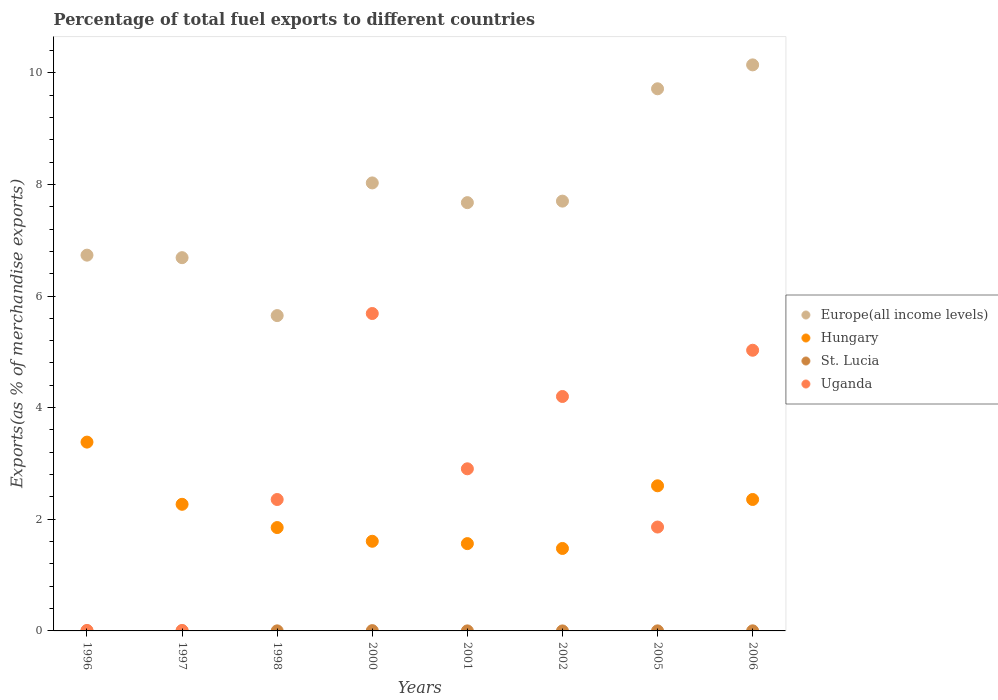How many different coloured dotlines are there?
Provide a short and direct response. 4. Is the number of dotlines equal to the number of legend labels?
Ensure brevity in your answer.  Yes. What is the percentage of exports to different countries in St. Lucia in 2002?
Ensure brevity in your answer.  4.657797227082891e-6. Across all years, what is the maximum percentage of exports to different countries in St. Lucia?
Give a very brief answer. 0.01. Across all years, what is the minimum percentage of exports to different countries in Uganda?
Provide a short and direct response. 0.01. What is the total percentage of exports to different countries in Europe(all income levels) in the graph?
Keep it short and to the point. 62.32. What is the difference between the percentage of exports to different countries in Hungary in 1996 and that in 2006?
Offer a terse response. 1.03. What is the difference between the percentage of exports to different countries in Uganda in 2000 and the percentage of exports to different countries in Hungary in 2001?
Ensure brevity in your answer.  4.12. What is the average percentage of exports to different countries in Hungary per year?
Make the answer very short. 2.14. In the year 1998, what is the difference between the percentage of exports to different countries in St. Lucia and percentage of exports to different countries in Uganda?
Your answer should be compact. -2.35. What is the ratio of the percentage of exports to different countries in Uganda in 2000 to that in 2005?
Your answer should be very brief. 3.06. What is the difference between the highest and the second highest percentage of exports to different countries in Uganda?
Your answer should be compact. 0.66. What is the difference between the highest and the lowest percentage of exports to different countries in St. Lucia?
Offer a terse response. 0.01. Is it the case that in every year, the sum of the percentage of exports to different countries in Hungary and percentage of exports to different countries in Europe(all income levels)  is greater than the percentage of exports to different countries in St. Lucia?
Give a very brief answer. Yes. Is the percentage of exports to different countries in St. Lucia strictly greater than the percentage of exports to different countries in Uganda over the years?
Give a very brief answer. No. Is the percentage of exports to different countries in St. Lucia strictly less than the percentage of exports to different countries in Hungary over the years?
Provide a succinct answer. Yes. How many years are there in the graph?
Ensure brevity in your answer.  8. What is the difference between two consecutive major ticks on the Y-axis?
Your response must be concise. 2. How many legend labels are there?
Make the answer very short. 4. What is the title of the graph?
Offer a terse response. Percentage of total fuel exports to different countries. Does "Bosnia and Herzegovina" appear as one of the legend labels in the graph?
Keep it short and to the point. No. What is the label or title of the X-axis?
Your answer should be very brief. Years. What is the label or title of the Y-axis?
Provide a short and direct response. Exports(as % of merchandise exports). What is the Exports(as % of merchandise exports) of Europe(all income levels) in 1996?
Provide a short and direct response. 6.73. What is the Exports(as % of merchandise exports) in Hungary in 1996?
Offer a terse response. 3.38. What is the Exports(as % of merchandise exports) in St. Lucia in 1996?
Your answer should be very brief. 0. What is the Exports(as % of merchandise exports) in Uganda in 1996?
Give a very brief answer. 0.01. What is the Exports(as % of merchandise exports) in Europe(all income levels) in 1997?
Keep it short and to the point. 6.69. What is the Exports(as % of merchandise exports) of Hungary in 1997?
Give a very brief answer. 2.27. What is the Exports(as % of merchandise exports) in St. Lucia in 1997?
Ensure brevity in your answer.  0. What is the Exports(as % of merchandise exports) of Uganda in 1997?
Make the answer very short. 0.01. What is the Exports(as % of merchandise exports) in Europe(all income levels) in 1998?
Offer a terse response. 5.65. What is the Exports(as % of merchandise exports) of Hungary in 1998?
Your answer should be very brief. 1.85. What is the Exports(as % of merchandise exports) of St. Lucia in 1998?
Provide a short and direct response. 0. What is the Exports(as % of merchandise exports) of Uganda in 1998?
Your answer should be compact. 2.35. What is the Exports(as % of merchandise exports) of Europe(all income levels) in 2000?
Give a very brief answer. 8.03. What is the Exports(as % of merchandise exports) of Hungary in 2000?
Your response must be concise. 1.61. What is the Exports(as % of merchandise exports) in St. Lucia in 2000?
Offer a very short reply. 0.01. What is the Exports(as % of merchandise exports) of Uganda in 2000?
Offer a terse response. 5.69. What is the Exports(as % of merchandise exports) in Europe(all income levels) in 2001?
Make the answer very short. 7.67. What is the Exports(as % of merchandise exports) in Hungary in 2001?
Offer a very short reply. 1.56. What is the Exports(as % of merchandise exports) of St. Lucia in 2001?
Offer a terse response. 0. What is the Exports(as % of merchandise exports) in Uganda in 2001?
Your answer should be very brief. 2.9. What is the Exports(as % of merchandise exports) in Europe(all income levels) in 2002?
Ensure brevity in your answer.  7.7. What is the Exports(as % of merchandise exports) of Hungary in 2002?
Offer a terse response. 1.48. What is the Exports(as % of merchandise exports) of St. Lucia in 2002?
Your response must be concise. 4.657797227082891e-6. What is the Exports(as % of merchandise exports) in Uganda in 2002?
Offer a very short reply. 4.2. What is the Exports(as % of merchandise exports) in Europe(all income levels) in 2005?
Provide a short and direct response. 9.71. What is the Exports(as % of merchandise exports) of Hungary in 2005?
Your response must be concise. 2.6. What is the Exports(as % of merchandise exports) in St. Lucia in 2005?
Give a very brief answer. 0. What is the Exports(as % of merchandise exports) in Uganda in 2005?
Your response must be concise. 1.86. What is the Exports(as % of merchandise exports) of Europe(all income levels) in 2006?
Provide a succinct answer. 10.14. What is the Exports(as % of merchandise exports) in Hungary in 2006?
Make the answer very short. 2.35. What is the Exports(as % of merchandise exports) in St. Lucia in 2006?
Give a very brief answer. 0. What is the Exports(as % of merchandise exports) of Uganda in 2006?
Make the answer very short. 5.03. Across all years, what is the maximum Exports(as % of merchandise exports) in Europe(all income levels)?
Give a very brief answer. 10.14. Across all years, what is the maximum Exports(as % of merchandise exports) in Hungary?
Your answer should be compact. 3.38. Across all years, what is the maximum Exports(as % of merchandise exports) in St. Lucia?
Offer a very short reply. 0.01. Across all years, what is the maximum Exports(as % of merchandise exports) of Uganda?
Give a very brief answer. 5.69. Across all years, what is the minimum Exports(as % of merchandise exports) of Europe(all income levels)?
Your response must be concise. 5.65. Across all years, what is the minimum Exports(as % of merchandise exports) of Hungary?
Make the answer very short. 1.48. Across all years, what is the minimum Exports(as % of merchandise exports) in St. Lucia?
Your response must be concise. 4.657797227082891e-6. Across all years, what is the minimum Exports(as % of merchandise exports) of Uganda?
Your answer should be compact. 0.01. What is the total Exports(as % of merchandise exports) in Europe(all income levels) in the graph?
Offer a very short reply. 62.32. What is the total Exports(as % of merchandise exports) in Hungary in the graph?
Offer a very short reply. 17.11. What is the total Exports(as % of merchandise exports) in St. Lucia in the graph?
Give a very brief answer. 0.01. What is the total Exports(as % of merchandise exports) in Uganda in the graph?
Provide a succinct answer. 22.05. What is the difference between the Exports(as % of merchandise exports) of Europe(all income levels) in 1996 and that in 1997?
Ensure brevity in your answer.  0.04. What is the difference between the Exports(as % of merchandise exports) in Hungary in 1996 and that in 1997?
Provide a short and direct response. 1.11. What is the difference between the Exports(as % of merchandise exports) of St. Lucia in 1996 and that in 1997?
Give a very brief answer. -0. What is the difference between the Exports(as % of merchandise exports) of Uganda in 1996 and that in 1997?
Offer a terse response. 0. What is the difference between the Exports(as % of merchandise exports) in Europe(all income levels) in 1996 and that in 1998?
Give a very brief answer. 1.08. What is the difference between the Exports(as % of merchandise exports) of Hungary in 1996 and that in 1998?
Provide a succinct answer. 1.53. What is the difference between the Exports(as % of merchandise exports) of St. Lucia in 1996 and that in 1998?
Give a very brief answer. -0. What is the difference between the Exports(as % of merchandise exports) in Uganda in 1996 and that in 1998?
Ensure brevity in your answer.  -2.35. What is the difference between the Exports(as % of merchandise exports) of Europe(all income levels) in 1996 and that in 2000?
Offer a very short reply. -1.29. What is the difference between the Exports(as % of merchandise exports) of Hungary in 1996 and that in 2000?
Offer a terse response. 1.78. What is the difference between the Exports(as % of merchandise exports) of St. Lucia in 1996 and that in 2000?
Keep it short and to the point. -0.01. What is the difference between the Exports(as % of merchandise exports) in Uganda in 1996 and that in 2000?
Provide a short and direct response. -5.68. What is the difference between the Exports(as % of merchandise exports) in Europe(all income levels) in 1996 and that in 2001?
Provide a short and direct response. -0.94. What is the difference between the Exports(as % of merchandise exports) of Hungary in 1996 and that in 2001?
Your answer should be compact. 1.82. What is the difference between the Exports(as % of merchandise exports) in St. Lucia in 1996 and that in 2001?
Give a very brief answer. -0. What is the difference between the Exports(as % of merchandise exports) of Uganda in 1996 and that in 2001?
Offer a terse response. -2.9. What is the difference between the Exports(as % of merchandise exports) of Europe(all income levels) in 1996 and that in 2002?
Provide a short and direct response. -0.97. What is the difference between the Exports(as % of merchandise exports) in Hungary in 1996 and that in 2002?
Your response must be concise. 1.91. What is the difference between the Exports(as % of merchandise exports) of St. Lucia in 1996 and that in 2002?
Offer a terse response. 0. What is the difference between the Exports(as % of merchandise exports) in Uganda in 1996 and that in 2002?
Keep it short and to the point. -4.19. What is the difference between the Exports(as % of merchandise exports) in Europe(all income levels) in 1996 and that in 2005?
Your answer should be very brief. -2.98. What is the difference between the Exports(as % of merchandise exports) in Hungary in 1996 and that in 2005?
Give a very brief answer. 0.78. What is the difference between the Exports(as % of merchandise exports) in St. Lucia in 1996 and that in 2005?
Provide a short and direct response. -0. What is the difference between the Exports(as % of merchandise exports) of Uganda in 1996 and that in 2005?
Keep it short and to the point. -1.85. What is the difference between the Exports(as % of merchandise exports) of Europe(all income levels) in 1996 and that in 2006?
Offer a terse response. -3.41. What is the difference between the Exports(as % of merchandise exports) in Hungary in 1996 and that in 2006?
Keep it short and to the point. 1.03. What is the difference between the Exports(as % of merchandise exports) in St. Lucia in 1996 and that in 2006?
Provide a short and direct response. -0. What is the difference between the Exports(as % of merchandise exports) of Uganda in 1996 and that in 2006?
Offer a very short reply. -5.02. What is the difference between the Exports(as % of merchandise exports) of Europe(all income levels) in 1997 and that in 1998?
Offer a very short reply. 1.04. What is the difference between the Exports(as % of merchandise exports) of Hungary in 1997 and that in 1998?
Offer a terse response. 0.42. What is the difference between the Exports(as % of merchandise exports) of St. Lucia in 1997 and that in 1998?
Make the answer very short. -0. What is the difference between the Exports(as % of merchandise exports) of Uganda in 1997 and that in 1998?
Your response must be concise. -2.35. What is the difference between the Exports(as % of merchandise exports) of Europe(all income levels) in 1997 and that in 2000?
Ensure brevity in your answer.  -1.34. What is the difference between the Exports(as % of merchandise exports) of Hungary in 1997 and that in 2000?
Keep it short and to the point. 0.66. What is the difference between the Exports(as % of merchandise exports) in St. Lucia in 1997 and that in 2000?
Your answer should be very brief. -0. What is the difference between the Exports(as % of merchandise exports) in Uganda in 1997 and that in 2000?
Offer a terse response. -5.68. What is the difference between the Exports(as % of merchandise exports) of Europe(all income levels) in 1997 and that in 2001?
Provide a short and direct response. -0.99. What is the difference between the Exports(as % of merchandise exports) of Hungary in 1997 and that in 2001?
Provide a succinct answer. 0.7. What is the difference between the Exports(as % of merchandise exports) of St. Lucia in 1997 and that in 2001?
Provide a succinct answer. 0. What is the difference between the Exports(as % of merchandise exports) in Uganda in 1997 and that in 2001?
Make the answer very short. -2.9. What is the difference between the Exports(as % of merchandise exports) of Europe(all income levels) in 1997 and that in 2002?
Give a very brief answer. -1.01. What is the difference between the Exports(as % of merchandise exports) in Hungary in 1997 and that in 2002?
Keep it short and to the point. 0.79. What is the difference between the Exports(as % of merchandise exports) of St. Lucia in 1997 and that in 2002?
Offer a terse response. 0. What is the difference between the Exports(as % of merchandise exports) in Uganda in 1997 and that in 2002?
Provide a short and direct response. -4.19. What is the difference between the Exports(as % of merchandise exports) of Europe(all income levels) in 1997 and that in 2005?
Make the answer very short. -3.03. What is the difference between the Exports(as % of merchandise exports) of Hungary in 1997 and that in 2005?
Your answer should be very brief. -0.33. What is the difference between the Exports(as % of merchandise exports) of St. Lucia in 1997 and that in 2005?
Give a very brief answer. -0. What is the difference between the Exports(as % of merchandise exports) of Uganda in 1997 and that in 2005?
Your answer should be very brief. -1.85. What is the difference between the Exports(as % of merchandise exports) of Europe(all income levels) in 1997 and that in 2006?
Provide a succinct answer. -3.45. What is the difference between the Exports(as % of merchandise exports) in Hungary in 1997 and that in 2006?
Your response must be concise. -0.09. What is the difference between the Exports(as % of merchandise exports) in St. Lucia in 1997 and that in 2006?
Make the answer very short. -0. What is the difference between the Exports(as % of merchandise exports) in Uganda in 1997 and that in 2006?
Keep it short and to the point. -5.02. What is the difference between the Exports(as % of merchandise exports) in Europe(all income levels) in 1998 and that in 2000?
Provide a short and direct response. -2.38. What is the difference between the Exports(as % of merchandise exports) in Hungary in 1998 and that in 2000?
Offer a terse response. 0.25. What is the difference between the Exports(as % of merchandise exports) in St. Lucia in 1998 and that in 2000?
Make the answer very short. -0. What is the difference between the Exports(as % of merchandise exports) of Uganda in 1998 and that in 2000?
Your answer should be compact. -3.33. What is the difference between the Exports(as % of merchandise exports) in Europe(all income levels) in 1998 and that in 2001?
Your response must be concise. -2.02. What is the difference between the Exports(as % of merchandise exports) of Hungary in 1998 and that in 2001?
Your response must be concise. 0.29. What is the difference between the Exports(as % of merchandise exports) of St. Lucia in 1998 and that in 2001?
Keep it short and to the point. 0. What is the difference between the Exports(as % of merchandise exports) of Uganda in 1998 and that in 2001?
Provide a short and direct response. -0.55. What is the difference between the Exports(as % of merchandise exports) of Europe(all income levels) in 1998 and that in 2002?
Keep it short and to the point. -2.05. What is the difference between the Exports(as % of merchandise exports) of Hungary in 1998 and that in 2002?
Offer a terse response. 0.37. What is the difference between the Exports(as % of merchandise exports) in St. Lucia in 1998 and that in 2002?
Keep it short and to the point. 0. What is the difference between the Exports(as % of merchandise exports) in Uganda in 1998 and that in 2002?
Provide a short and direct response. -1.85. What is the difference between the Exports(as % of merchandise exports) in Europe(all income levels) in 1998 and that in 2005?
Keep it short and to the point. -4.06. What is the difference between the Exports(as % of merchandise exports) of Hungary in 1998 and that in 2005?
Your answer should be very brief. -0.75. What is the difference between the Exports(as % of merchandise exports) of Uganda in 1998 and that in 2005?
Give a very brief answer. 0.49. What is the difference between the Exports(as % of merchandise exports) in Europe(all income levels) in 1998 and that in 2006?
Ensure brevity in your answer.  -4.49. What is the difference between the Exports(as % of merchandise exports) in Hungary in 1998 and that in 2006?
Keep it short and to the point. -0.5. What is the difference between the Exports(as % of merchandise exports) of St. Lucia in 1998 and that in 2006?
Your response must be concise. -0. What is the difference between the Exports(as % of merchandise exports) of Uganda in 1998 and that in 2006?
Your answer should be compact. -2.67. What is the difference between the Exports(as % of merchandise exports) of Europe(all income levels) in 2000 and that in 2001?
Your answer should be compact. 0.35. What is the difference between the Exports(as % of merchandise exports) in Hungary in 2000 and that in 2001?
Keep it short and to the point. 0.04. What is the difference between the Exports(as % of merchandise exports) of St. Lucia in 2000 and that in 2001?
Keep it short and to the point. 0. What is the difference between the Exports(as % of merchandise exports) in Uganda in 2000 and that in 2001?
Provide a short and direct response. 2.78. What is the difference between the Exports(as % of merchandise exports) of Europe(all income levels) in 2000 and that in 2002?
Keep it short and to the point. 0.33. What is the difference between the Exports(as % of merchandise exports) of Hungary in 2000 and that in 2002?
Your answer should be compact. 0.13. What is the difference between the Exports(as % of merchandise exports) of St. Lucia in 2000 and that in 2002?
Make the answer very short. 0.01. What is the difference between the Exports(as % of merchandise exports) of Uganda in 2000 and that in 2002?
Provide a short and direct response. 1.49. What is the difference between the Exports(as % of merchandise exports) in Europe(all income levels) in 2000 and that in 2005?
Offer a terse response. -1.69. What is the difference between the Exports(as % of merchandise exports) in Hungary in 2000 and that in 2005?
Your answer should be compact. -0.99. What is the difference between the Exports(as % of merchandise exports) of St. Lucia in 2000 and that in 2005?
Offer a very short reply. 0. What is the difference between the Exports(as % of merchandise exports) of Uganda in 2000 and that in 2005?
Your answer should be very brief. 3.83. What is the difference between the Exports(as % of merchandise exports) in Europe(all income levels) in 2000 and that in 2006?
Provide a short and direct response. -2.11. What is the difference between the Exports(as % of merchandise exports) in Hungary in 2000 and that in 2006?
Ensure brevity in your answer.  -0.75. What is the difference between the Exports(as % of merchandise exports) of St. Lucia in 2000 and that in 2006?
Provide a succinct answer. 0. What is the difference between the Exports(as % of merchandise exports) in Uganda in 2000 and that in 2006?
Offer a terse response. 0.66. What is the difference between the Exports(as % of merchandise exports) of Europe(all income levels) in 2001 and that in 2002?
Make the answer very short. -0.03. What is the difference between the Exports(as % of merchandise exports) of Hungary in 2001 and that in 2002?
Offer a terse response. 0.09. What is the difference between the Exports(as % of merchandise exports) of St. Lucia in 2001 and that in 2002?
Make the answer very short. 0. What is the difference between the Exports(as % of merchandise exports) of Uganda in 2001 and that in 2002?
Your answer should be compact. -1.3. What is the difference between the Exports(as % of merchandise exports) of Europe(all income levels) in 2001 and that in 2005?
Your answer should be compact. -2.04. What is the difference between the Exports(as % of merchandise exports) of Hungary in 2001 and that in 2005?
Offer a very short reply. -1.04. What is the difference between the Exports(as % of merchandise exports) of St. Lucia in 2001 and that in 2005?
Keep it short and to the point. -0. What is the difference between the Exports(as % of merchandise exports) of Uganda in 2001 and that in 2005?
Give a very brief answer. 1.04. What is the difference between the Exports(as % of merchandise exports) of Europe(all income levels) in 2001 and that in 2006?
Provide a succinct answer. -2.47. What is the difference between the Exports(as % of merchandise exports) of Hungary in 2001 and that in 2006?
Offer a very short reply. -0.79. What is the difference between the Exports(as % of merchandise exports) in St. Lucia in 2001 and that in 2006?
Your response must be concise. -0. What is the difference between the Exports(as % of merchandise exports) in Uganda in 2001 and that in 2006?
Provide a succinct answer. -2.12. What is the difference between the Exports(as % of merchandise exports) of Europe(all income levels) in 2002 and that in 2005?
Offer a very short reply. -2.01. What is the difference between the Exports(as % of merchandise exports) in Hungary in 2002 and that in 2005?
Provide a short and direct response. -1.12. What is the difference between the Exports(as % of merchandise exports) in St. Lucia in 2002 and that in 2005?
Offer a very short reply. -0. What is the difference between the Exports(as % of merchandise exports) in Uganda in 2002 and that in 2005?
Provide a short and direct response. 2.34. What is the difference between the Exports(as % of merchandise exports) in Europe(all income levels) in 2002 and that in 2006?
Your answer should be very brief. -2.44. What is the difference between the Exports(as % of merchandise exports) of Hungary in 2002 and that in 2006?
Offer a terse response. -0.88. What is the difference between the Exports(as % of merchandise exports) of St. Lucia in 2002 and that in 2006?
Keep it short and to the point. -0. What is the difference between the Exports(as % of merchandise exports) of Uganda in 2002 and that in 2006?
Make the answer very short. -0.83. What is the difference between the Exports(as % of merchandise exports) in Europe(all income levels) in 2005 and that in 2006?
Offer a terse response. -0.43. What is the difference between the Exports(as % of merchandise exports) in Hungary in 2005 and that in 2006?
Your answer should be compact. 0.25. What is the difference between the Exports(as % of merchandise exports) of St. Lucia in 2005 and that in 2006?
Make the answer very short. -0. What is the difference between the Exports(as % of merchandise exports) of Uganda in 2005 and that in 2006?
Ensure brevity in your answer.  -3.17. What is the difference between the Exports(as % of merchandise exports) in Europe(all income levels) in 1996 and the Exports(as % of merchandise exports) in Hungary in 1997?
Offer a very short reply. 4.46. What is the difference between the Exports(as % of merchandise exports) in Europe(all income levels) in 1996 and the Exports(as % of merchandise exports) in St. Lucia in 1997?
Provide a succinct answer. 6.73. What is the difference between the Exports(as % of merchandise exports) of Europe(all income levels) in 1996 and the Exports(as % of merchandise exports) of Uganda in 1997?
Ensure brevity in your answer.  6.72. What is the difference between the Exports(as % of merchandise exports) in Hungary in 1996 and the Exports(as % of merchandise exports) in St. Lucia in 1997?
Ensure brevity in your answer.  3.38. What is the difference between the Exports(as % of merchandise exports) in Hungary in 1996 and the Exports(as % of merchandise exports) in Uganda in 1997?
Ensure brevity in your answer.  3.37. What is the difference between the Exports(as % of merchandise exports) of St. Lucia in 1996 and the Exports(as % of merchandise exports) of Uganda in 1997?
Provide a short and direct response. -0.01. What is the difference between the Exports(as % of merchandise exports) of Europe(all income levels) in 1996 and the Exports(as % of merchandise exports) of Hungary in 1998?
Provide a short and direct response. 4.88. What is the difference between the Exports(as % of merchandise exports) in Europe(all income levels) in 1996 and the Exports(as % of merchandise exports) in St. Lucia in 1998?
Provide a short and direct response. 6.73. What is the difference between the Exports(as % of merchandise exports) in Europe(all income levels) in 1996 and the Exports(as % of merchandise exports) in Uganda in 1998?
Offer a terse response. 4.38. What is the difference between the Exports(as % of merchandise exports) of Hungary in 1996 and the Exports(as % of merchandise exports) of St. Lucia in 1998?
Provide a succinct answer. 3.38. What is the difference between the Exports(as % of merchandise exports) of Hungary in 1996 and the Exports(as % of merchandise exports) of Uganda in 1998?
Ensure brevity in your answer.  1.03. What is the difference between the Exports(as % of merchandise exports) of St. Lucia in 1996 and the Exports(as % of merchandise exports) of Uganda in 1998?
Give a very brief answer. -2.35. What is the difference between the Exports(as % of merchandise exports) in Europe(all income levels) in 1996 and the Exports(as % of merchandise exports) in Hungary in 2000?
Give a very brief answer. 5.13. What is the difference between the Exports(as % of merchandise exports) in Europe(all income levels) in 1996 and the Exports(as % of merchandise exports) in St. Lucia in 2000?
Provide a short and direct response. 6.73. What is the difference between the Exports(as % of merchandise exports) of Europe(all income levels) in 1996 and the Exports(as % of merchandise exports) of Uganda in 2000?
Your response must be concise. 1.05. What is the difference between the Exports(as % of merchandise exports) in Hungary in 1996 and the Exports(as % of merchandise exports) in St. Lucia in 2000?
Your response must be concise. 3.38. What is the difference between the Exports(as % of merchandise exports) of Hungary in 1996 and the Exports(as % of merchandise exports) of Uganda in 2000?
Ensure brevity in your answer.  -2.3. What is the difference between the Exports(as % of merchandise exports) of St. Lucia in 1996 and the Exports(as % of merchandise exports) of Uganda in 2000?
Offer a very short reply. -5.69. What is the difference between the Exports(as % of merchandise exports) in Europe(all income levels) in 1996 and the Exports(as % of merchandise exports) in Hungary in 2001?
Ensure brevity in your answer.  5.17. What is the difference between the Exports(as % of merchandise exports) in Europe(all income levels) in 1996 and the Exports(as % of merchandise exports) in St. Lucia in 2001?
Your response must be concise. 6.73. What is the difference between the Exports(as % of merchandise exports) in Europe(all income levels) in 1996 and the Exports(as % of merchandise exports) in Uganda in 2001?
Give a very brief answer. 3.83. What is the difference between the Exports(as % of merchandise exports) in Hungary in 1996 and the Exports(as % of merchandise exports) in St. Lucia in 2001?
Keep it short and to the point. 3.38. What is the difference between the Exports(as % of merchandise exports) in Hungary in 1996 and the Exports(as % of merchandise exports) in Uganda in 2001?
Offer a terse response. 0.48. What is the difference between the Exports(as % of merchandise exports) of St. Lucia in 1996 and the Exports(as % of merchandise exports) of Uganda in 2001?
Your response must be concise. -2.9. What is the difference between the Exports(as % of merchandise exports) of Europe(all income levels) in 1996 and the Exports(as % of merchandise exports) of Hungary in 2002?
Ensure brevity in your answer.  5.25. What is the difference between the Exports(as % of merchandise exports) of Europe(all income levels) in 1996 and the Exports(as % of merchandise exports) of St. Lucia in 2002?
Make the answer very short. 6.73. What is the difference between the Exports(as % of merchandise exports) of Europe(all income levels) in 1996 and the Exports(as % of merchandise exports) of Uganda in 2002?
Your response must be concise. 2.53. What is the difference between the Exports(as % of merchandise exports) of Hungary in 1996 and the Exports(as % of merchandise exports) of St. Lucia in 2002?
Give a very brief answer. 3.38. What is the difference between the Exports(as % of merchandise exports) of Hungary in 1996 and the Exports(as % of merchandise exports) of Uganda in 2002?
Your response must be concise. -0.82. What is the difference between the Exports(as % of merchandise exports) in St. Lucia in 1996 and the Exports(as % of merchandise exports) in Uganda in 2002?
Your response must be concise. -4.2. What is the difference between the Exports(as % of merchandise exports) of Europe(all income levels) in 1996 and the Exports(as % of merchandise exports) of Hungary in 2005?
Offer a terse response. 4.13. What is the difference between the Exports(as % of merchandise exports) in Europe(all income levels) in 1996 and the Exports(as % of merchandise exports) in St. Lucia in 2005?
Keep it short and to the point. 6.73. What is the difference between the Exports(as % of merchandise exports) of Europe(all income levels) in 1996 and the Exports(as % of merchandise exports) of Uganda in 2005?
Offer a very short reply. 4.87. What is the difference between the Exports(as % of merchandise exports) in Hungary in 1996 and the Exports(as % of merchandise exports) in St. Lucia in 2005?
Your response must be concise. 3.38. What is the difference between the Exports(as % of merchandise exports) in Hungary in 1996 and the Exports(as % of merchandise exports) in Uganda in 2005?
Keep it short and to the point. 1.52. What is the difference between the Exports(as % of merchandise exports) of St. Lucia in 1996 and the Exports(as % of merchandise exports) of Uganda in 2005?
Provide a succinct answer. -1.86. What is the difference between the Exports(as % of merchandise exports) of Europe(all income levels) in 1996 and the Exports(as % of merchandise exports) of Hungary in 2006?
Provide a short and direct response. 4.38. What is the difference between the Exports(as % of merchandise exports) in Europe(all income levels) in 1996 and the Exports(as % of merchandise exports) in St. Lucia in 2006?
Keep it short and to the point. 6.73. What is the difference between the Exports(as % of merchandise exports) of Europe(all income levels) in 1996 and the Exports(as % of merchandise exports) of Uganda in 2006?
Make the answer very short. 1.7. What is the difference between the Exports(as % of merchandise exports) in Hungary in 1996 and the Exports(as % of merchandise exports) in St. Lucia in 2006?
Offer a very short reply. 3.38. What is the difference between the Exports(as % of merchandise exports) of Hungary in 1996 and the Exports(as % of merchandise exports) of Uganda in 2006?
Provide a succinct answer. -1.65. What is the difference between the Exports(as % of merchandise exports) of St. Lucia in 1996 and the Exports(as % of merchandise exports) of Uganda in 2006?
Offer a terse response. -5.03. What is the difference between the Exports(as % of merchandise exports) of Europe(all income levels) in 1997 and the Exports(as % of merchandise exports) of Hungary in 1998?
Keep it short and to the point. 4.84. What is the difference between the Exports(as % of merchandise exports) of Europe(all income levels) in 1997 and the Exports(as % of merchandise exports) of St. Lucia in 1998?
Provide a short and direct response. 6.69. What is the difference between the Exports(as % of merchandise exports) of Europe(all income levels) in 1997 and the Exports(as % of merchandise exports) of Uganda in 1998?
Ensure brevity in your answer.  4.33. What is the difference between the Exports(as % of merchandise exports) in Hungary in 1997 and the Exports(as % of merchandise exports) in St. Lucia in 1998?
Offer a very short reply. 2.27. What is the difference between the Exports(as % of merchandise exports) of Hungary in 1997 and the Exports(as % of merchandise exports) of Uganda in 1998?
Offer a very short reply. -0.09. What is the difference between the Exports(as % of merchandise exports) of St. Lucia in 1997 and the Exports(as % of merchandise exports) of Uganda in 1998?
Offer a terse response. -2.35. What is the difference between the Exports(as % of merchandise exports) of Europe(all income levels) in 1997 and the Exports(as % of merchandise exports) of Hungary in 2000?
Make the answer very short. 5.08. What is the difference between the Exports(as % of merchandise exports) in Europe(all income levels) in 1997 and the Exports(as % of merchandise exports) in St. Lucia in 2000?
Offer a very short reply. 6.68. What is the difference between the Exports(as % of merchandise exports) in Hungary in 1997 and the Exports(as % of merchandise exports) in St. Lucia in 2000?
Offer a very short reply. 2.26. What is the difference between the Exports(as % of merchandise exports) in Hungary in 1997 and the Exports(as % of merchandise exports) in Uganda in 2000?
Offer a very short reply. -3.42. What is the difference between the Exports(as % of merchandise exports) of St. Lucia in 1997 and the Exports(as % of merchandise exports) of Uganda in 2000?
Offer a very short reply. -5.69. What is the difference between the Exports(as % of merchandise exports) of Europe(all income levels) in 1997 and the Exports(as % of merchandise exports) of Hungary in 2001?
Your response must be concise. 5.12. What is the difference between the Exports(as % of merchandise exports) of Europe(all income levels) in 1997 and the Exports(as % of merchandise exports) of St. Lucia in 2001?
Offer a terse response. 6.69. What is the difference between the Exports(as % of merchandise exports) of Europe(all income levels) in 1997 and the Exports(as % of merchandise exports) of Uganda in 2001?
Ensure brevity in your answer.  3.78. What is the difference between the Exports(as % of merchandise exports) in Hungary in 1997 and the Exports(as % of merchandise exports) in St. Lucia in 2001?
Ensure brevity in your answer.  2.27. What is the difference between the Exports(as % of merchandise exports) of Hungary in 1997 and the Exports(as % of merchandise exports) of Uganda in 2001?
Make the answer very short. -0.64. What is the difference between the Exports(as % of merchandise exports) in St. Lucia in 1997 and the Exports(as % of merchandise exports) in Uganda in 2001?
Your answer should be very brief. -2.9. What is the difference between the Exports(as % of merchandise exports) of Europe(all income levels) in 1997 and the Exports(as % of merchandise exports) of Hungary in 2002?
Your response must be concise. 5.21. What is the difference between the Exports(as % of merchandise exports) of Europe(all income levels) in 1997 and the Exports(as % of merchandise exports) of St. Lucia in 2002?
Ensure brevity in your answer.  6.69. What is the difference between the Exports(as % of merchandise exports) of Europe(all income levels) in 1997 and the Exports(as % of merchandise exports) of Uganda in 2002?
Offer a very short reply. 2.49. What is the difference between the Exports(as % of merchandise exports) in Hungary in 1997 and the Exports(as % of merchandise exports) in St. Lucia in 2002?
Your response must be concise. 2.27. What is the difference between the Exports(as % of merchandise exports) of Hungary in 1997 and the Exports(as % of merchandise exports) of Uganda in 2002?
Offer a very short reply. -1.93. What is the difference between the Exports(as % of merchandise exports) of St. Lucia in 1997 and the Exports(as % of merchandise exports) of Uganda in 2002?
Offer a terse response. -4.2. What is the difference between the Exports(as % of merchandise exports) of Europe(all income levels) in 1997 and the Exports(as % of merchandise exports) of Hungary in 2005?
Make the answer very short. 4.09. What is the difference between the Exports(as % of merchandise exports) of Europe(all income levels) in 1997 and the Exports(as % of merchandise exports) of St. Lucia in 2005?
Offer a terse response. 6.69. What is the difference between the Exports(as % of merchandise exports) of Europe(all income levels) in 1997 and the Exports(as % of merchandise exports) of Uganda in 2005?
Your answer should be compact. 4.83. What is the difference between the Exports(as % of merchandise exports) of Hungary in 1997 and the Exports(as % of merchandise exports) of St. Lucia in 2005?
Your answer should be very brief. 2.27. What is the difference between the Exports(as % of merchandise exports) in Hungary in 1997 and the Exports(as % of merchandise exports) in Uganda in 2005?
Give a very brief answer. 0.41. What is the difference between the Exports(as % of merchandise exports) of St. Lucia in 1997 and the Exports(as % of merchandise exports) of Uganda in 2005?
Provide a short and direct response. -1.86. What is the difference between the Exports(as % of merchandise exports) in Europe(all income levels) in 1997 and the Exports(as % of merchandise exports) in Hungary in 2006?
Keep it short and to the point. 4.33. What is the difference between the Exports(as % of merchandise exports) of Europe(all income levels) in 1997 and the Exports(as % of merchandise exports) of St. Lucia in 2006?
Ensure brevity in your answer.  6.69. What is the difference between the Exports(as % of merchandise exports) in Europe(all income levels) in 1997 and the Exports(as % of merchandise exports) in Uganda in 2006?
Offer a very short reply. 1.66. What is the difference between the Exports(as % of merchandise exports) of Hungary in 1997 and the Exports(as % of merchandise exports) of St. Lucia in 2006?
Keep it short and to the point. 2.27. What is the difference between the Exports(as % of merchandise exports) in Hungary in 1997 and the Exports(as % of merchandise exports) in Uganda in 2006?
Your answer should be very brief. -2.76. What is the difference between the Exports(as % of merchandise exports) of St. Lucia in 1997 and the Exports(as % of merchandise exports) of Uganda in 2006?
Your answer should be very brief. -5.03. What is the difference between the Exports(as % of merchandise exports) of Europe(all income levels) in 1998 and the Exports(as % of merchandise exports) of Hungary in 2000?
Provide a succinct answer. 4.04. What is the difference between the Exports(as % of merchandise exports) in Europe(all income levels) in 1998 and the Exports(as % of merchandise exports) in St. Lucia in 2000?
Your response must be concise. 5.64. What is the difference between the Exports(as % of merchandise exports) in Europe(all income levels) in 1998 and the Exports(as % of merchandise exports) in Uganda in 2000?
Offer a very short reply. -0.04. What is the difference between the Exports(as % of merchandise exports) in Hungary in 1998 and the Exports(as % of merchandise exports) in St. Lucia in 2000?
Ensure brevity in your answer.  1.85. What is the difference between the Exports(as % of merchandise exports) in Hungary in 1998 and the Exports(as % of merchandise exports) in Uganda in 2000?
Offer a very short reply. -3.83. What is the difference between the Exports(as % of merchandise exports) of St. Lucia in 1998 and the Exports(as % of merchandise exports) of Uganda in 2000?
Keep it short and to the point. -5.69. What is the difference between the Exports(as % of merchandise exports) in Europe(all income levels) in 1998 and the Exports(as % of merchandise exports) in Hungary in 2001?
Ensure brevity in your answer.  4.09. What is the difference between the Exports(as % of merchandise exports) in Europe(all income levels) in 1998 and the Exports(as % of merchandise exports) in St. Lucia in 2001?
Give a very brief answer. 5.65. What is the difference between the Exports(as % of merchandise exports) in Europe(all income levels) in 1998 and the Exports(as % of merchandise exports) in Uganda in 2001?
Keep it short and to the point. 2.74. What is the difference between the Exports(as % of merchandise exports) of Hungary in 1998 and the Exports(as % of merchandise exports) of St. Lucia in 2001?
Give a very brief answer. 1.85. What is the difference between the Exports(as % of merchandise exports) of Hungary in 1998 and the Exports(as % of merchandise exports) of Uganda in 2001?
Your response must be concise. -1.05. What is the difference between the Exports(as % of merchandise exports) of St. Lucia in 1998 and the Exports(as % of merchandise exports) of Uganda in 2001?
Make the answer very short. -2.9. What is the difference between the Exports(as % of merchandise exports) of Europe(all income levels) in 1998 and the Exports(as % of merchandise exports) of Hungary in 2002?
Make the answer very short. 4.17. What is the difference between the Exports(as % of merchandise exports) in Europe(all income levels) in 1998 and the Exports(as % of merchandise exports) in St. Lucia in 2002?
Keep it short and to the point. 5.65. What is the difference between the Exports(as % of merchandise exports) of Europe(all income levels) in 1998 and the Exports(as % of merchandise exports) of Uganda in 2002?
Your response must be concise. 1.45. What is the difference between the Exports(as % of merchandise exports) in Hungary in 1998 and the Exports(as % of merchandise exports) in St. Lucia in 2002?
Provide a succinct answer. 1.85. What is the difference between the Exports(as % of merchandise exports) of Hungary in 1998 and the Exports(as % of merchandise exports) of Uganda in 2002?
Your response must be concise. -2.35. What is the difference between the Exports(as % of merchandise exports) of St. Lucia in 1998 and the Exports(as % of merchandise exports) of Uganda in 2002?
Ensure brevity in your answer.  -4.2. What is the difference between the Exports(as % of merchandise exports) in Europe(all income levels) in 1998 and the Exports(as % of merchandise exports) in Hungary in 2005?
Give a very brief answer. 3.05. What is the difference between the Exports(as % of merchandise exports) in Europe(all income levels) in 1998 and the Exports(as % of merchandise exports) in St. Lucia in 2005?
Your answer should be very brief. 5.65. What is the difference between the Exports(as % of merchandise exports) of Europe(all income levels) in 1998 and the Exports(as % of merchandise exports) of Uganda in 2005?
Your answer should be very brief. 3.79. What is the difference between the Exports(as % of merchandise exports) of Hungary in 1998 and the Exports(as % of merchandise exports) of St. Lucia in 2005?
Your answer should be compact. 1.85. What is the difference between the Exports(as % of merchandise exports) in Hungary in 1998 and the Exports(as % of merchandise exports) in Uganda in 2005?
Keep it short and to the point. -0.01. What is the difference between the Exports(as % of merchandise exports) in St. Lucia in 1998 and the Exports(as % of merchandise exports) in Uganda in 2005?
Offer a terse response. -1.86. What is the difference between the Exports(as % of merchandise exports) in Europe(all income levels) in 1998 and the Exports(as % of merchandise exports) in Hungary in 2006?
Offer a very short reply. 3.29. What is the difference between the Exports(as % of merchandise exports) of Europe(all income levels) in 1998 and the Exports(as % of merchandise exports) of St. Lucia in 2006?
Ensure brevity in your answer.  5.65. What is the difference between the Exports(as % of merchandise exports) of Europe(all income levels) in 1998 and the Exports(as % of merchandise exports) of Uganda in 2006?
Make the answer very short. 0.62. What is the difference between the Exports(as % of merchandise exports) in Hungary in 1998 and the Exports(as % of merchandise exports) in St. Lucia in 2006?
Give a very brief answer. 1.85. What is the difference between the Exports(as % of merchandise exports) of Hungary in 1998 and the Exports(as % of merchandise exports) of Uganda in 2006?
Ensure brevity in your answer.  -3.18. What is the difference between the Exports(as % of merchandise exports) of St. Lucia in 1998 and the Exports(as % of merchandise exports) of Uganda in 2006?
Your answer should be compact. -5.03. What is the difference between the Exports(as % of merchandise exports) of Europe(all income levels) in 2000 and the Exports(as % of merchandise exports) of Hungary in 2001?
Offer a terse response. 6.46. What is the difference between the Exports(as % of merchandise exports) of Europe(all income levels) in 2000 and the Exports(as % of merchandise exports) of St. Lucia in 2001?
Offer a very short reply. 8.03. What is the difference between the Exports(as % of merchandise exports) of Europe(all income levels) in 2000 and the Exports(as % of merchandise exports) of Uganda in 2001?
Provide a short and direct response. 5.12. What is the difference between the Exports(as % of merchandise exports) in Hungary in 2000 and the Exports(as % of merchandise exports) in St. Lucia in 2001?
Make the answer very short. 1.61. What is the difference between the Exports(as % of merchandise exports) in Hungary in 2000 and the Exports(as % of merchandise exports) in Uganda in 2001?
Keep it short and to the point. -1.3. What is the difference between the Exports(as % of merchandise exports) in St. Lucia in 2000 and the Exports(as % of merchandise exports) in Uganda in 2001?
Provide a succinct answer. -2.9. What is the difference between the Exports(as % of merchandise exports) of Europe(all income levels) in 2000 and the Exports(as % of merchandise exports) of Hungary in 2002?
Keep it short and to the point. 6.55. What is the difference between the Exports(as % of merchandise exports) of Europe(all income levels) in 2000 and the Exports(as % of merchandise exports) of St. Lucia in 2002?
Provide a short and direct response. 8.03. What is the difference between the Exports(as % of merchandise exports) in Europe(all income levels) in 2000 and the Exports(as % of merchandise exports) in Uganda in 2002?
Provide a short and direct response. 3.83. What is the difference between the Exports(as % of merchandise exports) of Hungary in 2000 and the Exports(as % of merchandise exports) of St. Lucia in 2002?
Offer a terse response. 1.61. What is the difference between the Exports(as % of merchandise exports) of Hungary in 2000 and the Exports(as % of merchandise exports) of Uganda in 2002?
Offer a terse response. -2.59. What is the difference between the Exports(as % of merchandise exports) of St. Lucia in 2000 and the Exports(as % of merchandise exports) of Uganda in 2002?
Offer a very short reply. -4.19. What is the difference between the Exports(as % of merchandise exports) of Europe(all income levels) in 2000 and the Exports(as % of merchandise exports) of Hungary in 2005?
Ensure brevity in your answer.  5.43. What is the difference between the Exports(as % of merchandise exports) of Europe(all income levels) in 2000 and the Exports(as % of merchandise exports) of St. Lucia in 2005?
Keep it short and to the point. 8.03. What is the difference between the Exports(as % of merchandise exports) in Europe(all income levels) in 2000 and the Exports(as % of merchandise exports) in Uganda in 2005?
Keep it short and to the point. 6.17. What is the difference between the Exports(as % of merchandise exports) in Hungary in 2000 and the Exports(as % of merchandise exports) in St. Lucia in 2005?
Keep it short and to the point. 1.61. What is the difference between the Exports(as % of merchandise exports) of Hungary in 2000 and the Exports(as % of merchandise exports) of Uganda in 2005?
Provide a short and direct response. -0.26. What is the difference between the Exports(as % of merchandise exports) of St. Lucia in 2000 and the Exports(as % of merchandise exports) of Uganda in 2005?
Your answer should be compact. -1.86. What is the difference between the Exports(as % of merchandise exports) in Europe(all income levels) in 2000 and the Exports(as % of merchandise exports) in Hungary in 2006?
Keep it short and to the point. 5.67. What is the difference between the Exports(as % of merchandise exports) in Europe(all income levels) in 2000 and the Exports(as % of merchandise exports) in St. Lucia in 2006?
Offer a very short reply. 8.02. What is the difference between the Exports(as % of merchandise exports) in Europe(all income levels) in 2000 and the Exports(as % of merchandise exports) in Uganda in 2006?
Offer a very short reply. 3. What is the difference between the Exports(as % of merchandise exports) of Hungary in 2000 and the Exports(as % of merchandise exports) of St. Lucia in 2006?
Make the answer very short. 1.6. What is the difference between the Exports(as % of merchandise exports) of Hungary in 2000 and the Exports(as % of merchandise exports) of Uganda in 2006?
Make the answer very short. -3.42. What is the difference between the Exports(as % of merchandise exports) in St. Lucia in 2000 and the Exports(as % of merchandise exports) in Uganda in 2006?
Make the answer very short. -5.02. What is the difference between the Exports(as % of merchandise exports) of Europe(all income levels) in 2001 and the Exports(as % of merchandise exports) of Hungary in 2002?
Your answer should be compact. 6.2. What is the difference between the Exports(as % of merchandise exports) of Europe(all income levels) in 2001 and the Exports(as % of merchandise exports) of St. Lucia in 2002?
Give a very brief answer. 7.67. What is the difference between the Exports(as % of merchandise exports) of Europe(all income levels) in 2001 and the Exports(as % of merchandise exports) of Uganda in 2002?
Give a very brief answer. 3.47. What is the difference between the Exports(as % of merchandise exports) in Hungary in 2001 and the Exports(as % of merchandise exports) in St. Lucia in 2002?
Offer a terse response. 1.56. What is the difference between the Exports(as % of merchandise exports) of Hungary in 2001 and the Exports(as % of merchandise exports) of Uganda in 2002?
Keep it short and to the point. -2.64. What is the difference between the Exports(as % of merchandise exports) of St. Lucia in 2001 and the Exports(as % of merchandise exports) of Uganda in 2002?
Your answer should be compact. -4.2. What is the difference between the Exports(as % of merchandise exports) of Europe(all income levels) in 2001 and the Exports(as % of merchandise exports) of Hungary in 2005?
Your answer should be very brief. 5.07. What is the difference between the Exports(as % of merchandise exports) of Europe(all income levels) in 2001 and the Exports(as % of merchandise exports) of St. Lucia in 2005?
Your response must be concise. 7.67. What is the difference between the Exports(as % of merchandise exports) in Europe(all income levels) in 2001 and the Exports(as % of merchandise exports) in Uganda in 2005?
Your answer should be compact. 5.81. What is the difference between the Exports(as % of merchandise exports) of Hungary in 2001 and the Exports(as % of merchandise exports) of St. Lucia in 2005?
Keep it short and to the point. 1.56. What is the difference between the Exports(as % of merchandise exports) in Hungary in 2001 and the Exports(as % of merchandise exports) in Uganda in 2005?
Your response must be concise. -0.3. What is the difference between the Exports(as % of merchandise exports) in St. Lucia in 2001 and the Exports(as % of merchandise exports) in Uganda in 2005?
Offer a terse response. -1.86. What is the difference between the Exports(as % of merchandise exports) in Europe(all income levels) in 2001 and the Exports(as % of merchandise exports) in Hungary in 2006?
Make the answer very short. 5.32. What is the difference between the Exports(as % of merchandise exports) of Europe(all income levels) in 2001 and the Exports(as % of merchandise exports) of St. Lucia in 2006?
Ensure brevity in your answer.  7.67. What is the difference between the Exports(as % of merchandise exports) of Europe(all income levels) in 2001 and the Exports(as % of merchandise exports) of Uganda in 2006?
Provide a succinct answer. 2.64. What is the difference between the Exports(as % of merchandise exports) in Hungary in 2001 and the Exports(as % of merchandise exports) in St. Lucia in 2006?
Provide a succinct answer. 1.56. What is the difference between the Exports(as % of merchandise exports) of Hungary in 2001 and the Exports(as % of merchandise exports) of Uganda in 2006?
Make the answer very short. -3.46. What is the difference between the Exports(as % of merchandise exports) of St. Lucia in 2001 and the Exports(as % of merchandise exports) of Uganda in 2006?
Your answer should be compact. -5.03. What is the difference between the Exports(as % of merchandise exports) of Europe(all income levels) in 2002 and the Exports(as % of merchandise exports) of Hungary in 2005?
Provide a succinct answer. 5.1. What is the difference between the Exports(as % of merchandise exports) in Europe(all income levels) in 2002 and the Exports(as % of merchandise exports) in St. Lucia in 2005?
Your response must be concise. 7.7. What is the difference between the Exports(as % of merchandise exports) in Europe(all income levels) in 2002 and the Exports(as % of merchandise exports) in Uganda in 2005?
Offer a very short reply. 5.84. What is the difference between the Exports(as % of merchandise exports) in Hungary in 2002 and the Exports(as % of merchandise exports) in St. Lucia in 2005?
Ensure brevity in your answer.  1.48. What is the difference between the Exports(as % of merchandise exports) of Hungary in 2002 and the Exports(as % of merchandise exports) of Uganda in 2005?
Give a very brief answer. -0.38. What is the difference between the Exports(as % of merchandise exports) of St. Lucia in 2002 and the Exports(as % of merchandise exports) of Uganda in 2005?
Provide a succinct answer. -1.86. What is the difference between the Exports(as % of merchandise exports) of Europe(all income levels) in 2002 and the Exports(as % of merchandise exports) of Hungary in 2006?
Your response must be concise. 5.35. What is the difference between the Exports(as % of merchandise exports) in Europe(all income levels) in 2002 and the Exports(as % of merchandise exports) in St. Lucia in 2006?
Give a very brief answer. 7.7. What is the difference between the Exports(as % of merchandise exports) in Europe(all income levels) in 2002 and the Exports(as % of merchandise exports) in Uganda in 2006?
Provide a short and direct response. 2.67. What is the difference between the Exports(as % of merchandise exports) of Hungary in 2002 and the Exports(as % of merchandise exports) of St. Lucia in 2006?
Ensure brevity in your answer.  1.48. What is the difference between the Exports(as % of merchandise exports) of Hungary in 2002 and the Exports(as % of merchandise exports) of Uganda in 2006?
Your answer should be compact. -3.55. What is the difference between the Exports(as % of merchandise exports) of St. Lucia in 2002 and the Exports(as % of merchandise exports) of Uganda in 2006?
Provide a short and direct response. -5.03. What is the difference between the Exports(as % of merchandise exports) of Europe(all income levels) in 2005 and the Exports(as % of merchandise exports) of Hungary in 2006?
Offer a terse response. 7.36. What is the difference between the Exports(as % of merchandise exports) in Europe(all income levels) in 2005 and the Exports(as % of merchandise exports) in St. Lucia in 2006?
Give a very brief answer. 9.71. What is the difference between the Exports(as % of merchandise exports) in Europe(all income levels) in 2005 and the Exports(as % of merchandise exports) in Uganda in 2006?
Your response must be concise. 4.68. What is the difference between the Exports(as % of merchandise exports) of Hungary in 2005 and the Exports(as % of merchandise exports) of St. Lucia in 2006?
Keep it short and to the point. 2.6. What is the difference between the Exports(as % of merchandise exports) in Hungary in 2005 and the Exports(as % of merchandise exports) in Uganda in 2006?
Give a very brief answer. -2.43. What is the difference between the Exports(as % of merchandise exports) in St. Lucia in 2005 and the Exports(as % of merchandise exports) in Uganda in 2006?
Provide a short and direct response. -5.03. What is the average Exports(as % of merchandise exports) of Europe(all income levels) per year?
Offer a very short reply. 7.79. What is the average Exports(as % of merchandise exports) of Hungary per year?
Give a very brief answer. 2.14. What is the average Exports(as % of merchandise exports) of St. Lucia per year?
Your answer should be very brief. 0. What is the average Exports(as % of merchandise exports) in Uganda per year?
Your answer should be very brief. 2.76. In the year 1996, what is the difference between the Exports(as % of merchandise exports) of Europe(all income levels) and Exports(as % of merchandise exports) of Hungary?
Your response must be concise. 3.35. In the year 1996, what is the difference between the Exports(as % of merchandise exports) of Europe(all income levels) and Exports(as % of merchandise exports) of St. Lucia?
Keep it short and to the point. 6.73. In the year 1996, what is the difference between the Exports(as % of merchandise exports) in Europe(all income levels) and Exports(as % of merchandise exports) in Uganda?
Keep it short and to the point. 6.72. In the year 1996, what is the difference between the Exports(as % of merchandise exports) in Hungary and Exports(as % of merchandise exports) in St. Lucia?
Your answer should be very brief. 3.38. In the year 1996, what is the difference between the Exports(as % of merchandise exports) in Hungary and Exports(as % of merchandise exports) in Uganda?
Your response must be concise. 3.37. In the year 1996, what is the difference between the Exports(as % of merchandise exports) of St. Lucia and Exports(as % of merchandise exports) of Uganda?
Your response must be concise. -0.01. In the year 1997, what is the difference between the Exports(as % of merchandise exports) of Europe(all income levels) and Exports(as % of merchandise exports) of Hungary?
Provide a short and direct response. 4.42. In the year 1997, what is the difference between the Exports(as % of merchandise exports) of Europe(all income levels) and Exports(as % of merchandise exports) of St. Lucia?
Provide a short and direct response. 6.69. In the year 1997, what is the difference between the Exports(as % of merchandise exports) of Europe(all income levels) and Exports(as % of merchandise exports) of Uganda?
Ensure brevity in your answer.  6.68. In the year 1997, what is the difference between the Exports(as % of merchandise exports) in Hungary and Exports(as % of merchandise exports) in St. Lucia?
Your answer should be very brief. 2.27. In the year 1997, what is the difference between the Exports(as % of merchandise exports) of Hungary and Exports(as % of merchandise exports) of Uganda?
Ensure brevity in your answer.  2.26. In the year 1997, what is the difference between the Exports(as % of merchandise exports) of St. Lucia and Exports(as % of merchandise exports) of Uganda?
Offer a very short reply. -0.01. In the year 1998, what is the difference between the Exports(as % of merchandise exports) in Europe(all income levels) and Exports(as % of merchandise exports) in Hungary?
Offer a terse response. 3.8. In the year 1998, what is the difference between the Exports(as % of merchandise exports) in Europe(all income levels) and Exports(as % of merchandise exports) in St. Lucia?
Keep it short and to the point. 5.65. In the year 1998, what is the difference between the Exports(as % of merchandise exports) in Europe(all income levels) and Exports(as % of merchandise exports) in Uganda?
Ensure brevity in your answer.  3.3. In the year 1998, what is the difference between the Exports(as % of merchandise exports) in Hungary and Exports(as % of merchandise exports) in St. Lucia?
Your response must be concise. 1.85. In the year 1998, what is the difference between the Exports(as % of merchandise exports) of Hungary and Exports(as % of merchandise exports) of Uganda?
Give a very brief answer. -0.5. In the year 1998, what is the difference between the Exports(as % of merchandise exports) of St. Lucia and Exports(as % of merchandise exports) of Uganda?
Your response must be concise. -2.35. In the year 2000, what is the difference between the Exports(as % of merchandise exports) in Europe(all income levels) and Exports(as % of merchandise exports) in Hungary?
Make the answer very short. 6.42. In the year 2000, what is the difference between the Exports(as % of merchandise exports) of Europe(all income levels) and Exports(as % of merchandise exports) of St. Lucia?
Your answer should be compact. 8.02. In the year 2000, what is the difference between the Exports(as % of merchandise exports) of Europe(all income levels) and Exports(as % of merchandise exports) of Uganda?
Ensure brevity in your answer.  2.34. In the year 2000, what is the difference between the Exports(as % of merchandise exports) in Hungary and Exports(as % of merchandise exports) in St. Lucia?
Provide a short and direct response. 1.6. In the year 2000, what is the difference between the Exports(as % of merchandise exports) in Hungary and Exports(as % of merchandise exports) in Uganda?
Provide a short and direct response. -4.08. In the year 2000, what is the difference between the Exports(as % of merchandise exports) in St. Lucia and Exports(as % of merchandise exports) in Uganda?
Ensure brevity in your answer.  -5.68. In the year 2001, what is the difference between the Exports(as % of merchandise exports) in Europe(all income levels) and Exports(as % of merchandise exports) in Hungary?
Provide a succinct answer. 6.11. In the year 2001, what is the difference between the Exports(as % of merchandise exports) in Europe(all income levels) and Exports(as % of merchandise exports) in St. Lucia?
Ensure brevity in your answer.  7.67. In the year 2001, what is the difference between the Exports(as % of merchandise exports) of Europe(all income levels) and Exports(as % of merchandise exports) of Uganda?
Your answer should be very brief. 4.77. In the year 2001, what is the difference between the Exports(as % of merchandise exports) in Hungary and Exports(as % of merchandise exports) in St. Lucia?
Keep it short and to the point. 1.56. In the year 2001, what is the difference between the Exports(as % of merchandise exports) in Hungary and Exports(as % of merchandise exports) in Uganda?
Keep it short and to the point. -1.34. In the year 2001, what is the difference between the Exports(as % of merchandise exports) of St. Lucia and Exports(as % of merchandise exports) of Uganda?
Ensure brevity in your answer.  -2.9. In the year 2002, what is the difference between the Exports(as % of merchandise exports) in Europe(all income levels) and Exports(as % of merchandise exports) in Hungary?
Keep it short and to the point. 6.22. In the year 2002, what is the difference between the Exports(as % of merchandise exports) in Europe(all income levels) and Exports(as % of merchandise exports) in St. Lucia?
Your answer should be very brief. 7.7. In the year 2002, what is the difference between the Exports(as % of merchandise exports) of Europe(all income levels) and Exports(as % of merchandise exports) of Uganda?
Provide a succinct answer. 3.5. In the year 2002, what is the difference between the Exports(as % of merchandise exports) in Hungary and Exports(as % of merchandise exports) in St. Lucia?
Give a very brief answer. 1.48. In the year 2002, what is the difference between the Exports(as % of merchandise exports) in Hungary and Exports(as % of merchandise exports) in Uganda?
Ensure brevity in your answer.  -2.72. In the year 2002, what is the difference between the Exports(as % of merchandise exports) of St. Lucia and Exports(as % of merchandise exports) of Uganda?
Provide a short and direct response. -4.2. In the year 2005, what is the difference between the Exports(as % of merchandise exports) in Europe(all income levels) and Exports(as % of merchandise exports) in Hungary?
Ensure brevity in your answer.  7.11. In the year 2005, what is the difference between the Exports(as % of merchandise exports) of Europe(all income levels) and Exports(as % of merchandise exports) of St. Lucia?
Offer a terse response. 9.71. In the year 2005, what is the difference between the Exports(as % of merchandise exports) of Europe(all income levels) and Exports(as % of merchandise exports) of Uganda?
Ensure brevity in your answer.  7.85. In the year 2005, what is the difference between the Exports(as % of merchandise exports) of Hungary and Exports(as % of merchandise exports) of St. Lucia?
Your answer should be compact. 2.6. In the year 2005, what is the difference between the Exports(as % of merchandise exports) in Hungary and Exports(as % of merchandise exports) in Uganda?
Offer a terse response. 0.74. In the year 2005, what is the difference between the Exports(as % of merchandise exports) in St. Lucia and Exports(as % of merchandise exports) in Uganda?
Make the answer very short. -1.86. In the year 2006, what is the difference between the Exports(as % of merchandise exports) in Europe(all income levels) and Exports(as % of merchandise exports) in Hungary?
Offer a very short reply. 7.79. In the year 2006, what is the difference between the Exports(as % of merchandise exports) of Europe(all income levels) and Exports(as % of merchandise exports) of St. Lucia?
Keep it short and to the point. 10.14. In the year 2006, what is the difference between the Exports(as % of merchandise exports) in Europe(all income levels) and Exports(as % of merchandise exports) in Uganda?
Your response must be concise. 5.11. In the year 2006, what is the difference between the Exports(as % of merchandise exports) of Hungary and Exports(as % of merchandise exports) of St. Lucia?
Make the answer very short. 2.35. In the year 2006, what is the difference between the Exports(as % of merchandise exports) in Hungary and Exports(as % of merchandise exports) in Uganda?
Provide a short and direct response. -2.67. In the year 2006, what is the difference between the Exports(as % of merchandise exports) in St. Lucia and Exports(as % of merchandise exports) in Uganda?
Your answer should be compact. -5.03. What is the ratio of the Exports(as % of merchandise exports) of Hungary in 1996 to that in 1997?
Your answer should be compact. 1.49. What is the ratio of the Exports(as % of merchandise exports) of St. Lucia in 1996 to that in 1997?
Keep it short and to the point. 0.18. What is the ratio of the Exports(as % of merchandise exports) of Uganda in 1996 to that in 1997?
Your answer should be very brief. 1.08. What is the ratio of the Exports(as % of merchandise exports) of Europe(all income levels) in 1996 to that in 1998?
Offer a terse response. 1.19. What is the ratio of the Exports(as % of merchandise exports) in Hungary in 1996 to that in 1998?
Offer a terse response. 1.83. What is the ratio of the Exports(as % of merchandise exports) of St. Lucia in 1996 to that in 1998?
Provide a short and direct response. 0.13. What is the ratio of the Exports(as % of merchandise exports) of Uganda in 1996 to that in 1998?
Provide a short and direct response. 0. What is the ratio of the Exports(as % of merchandise exports) in Europe(all income levels) in 1996 to that in 2000?
Your answer should be very brief. 0.84. What is the ratio of the Exports(as % of merchandise exports) of Hungary in 1996 to that in 2000?
Ensure brevity in your answer.  2.11. What is the ratio of the Exports(as % of merchandise exports) in St. Lucia in 1996 to that in 2000?
Provide a succinct answer. 0.03. What is the ratio of the Exports(as % of merchandise exports) of Uganda in 1996 to that in 2000?
Keep it short and to the point. 0. What is the ratio of the Exports(as % of merchandise exports) of Europe(all income levels) in 1996 to that in 2001?
Keep it short and to the point. 0.88. What is the ratio of the Exports(as % of merchandise exports) in Hungary in 1996 to that in 2001?
Your answer should be compact. 2.16. What is the ratio of the Exports(as % of merchandise exports) of St. Lucia in 1996 to that in 2001?
Give a very brief answer. 0.25. What is the ratio of the Exports(as % of merchandise exports) in Uganda in 1996 to that in 2001?
Your answer should be compact. 0. What is the ratio of the Exports(as % of merchandise exports) of Europe(all income levels) in 1996 to that in 2002?
Make the answer very short. 0.87. What is the ratio of the Exports(as % of merchandise exports) in Hungary in 1996 to that in 2002?
Give a very brief answer. 2.29. What is the ratio of the Exports(as % of merchandise exports) in St. Lucia in 1996 to that in 2002?
Your response must be concise. 30.88. What is the ratio of the Exports(as % of merchandise exports) in Uganda in 1996 to that in 2002?
Your answer should be compact. 0. What is the ratio of the Exports(as % of merchandise exports) of Europe(all income levels) in 1996 to that in 2005?
Give a very brief answer. 0.69. What is the ratio of the Exports(as % of merchandise exports) in Hungary in 1996 to that in 2005?
Ensure brevity in your answer.  1.3. What is the ratio of the Exports(as % of merchandise exports) of St. Lucia in 1996 to that in 2005?
Give a very brief answer. 0.14. What is the ratio of the Exports(as % of merchandise exports) of Uganda in 1996 to that in 2005?
Your answer should be very brief. 0. What is the ratio of the Exports(as % of merchandise exports) of Europe(all income levels) in 1996 to that in 2006?
Make the answer very short. 0.66. What is the ratio of the Exports(as % of merchandise exports) of Hungary in 1996 to that in 2006?
Provide a short and direct response. 1.44. What is the ratio of the Exports(as % of merchandise exports) of St. Lucia in 1996 to that in 2006?
Give a very brief answer. 0.09. What is the ratio of the Exports(as % of merchandise exports) in Uganda in 1996 to that in 2006?
Ensure brevity in your answer.  0. What is the ratio of the Exports(as % of merchandise exports) of Europe(all income levels) in 1997 to that in 1998?
Make the answer very short. 1.18. What is the ratio of the Exports(as % of merchandise exports) of Hungary in 1997 to that in 1998?
Offer a terse response. 1.22. What is the ratio of the Exports(as % of merchandise exports) in St. Lucia in 1997 to that in 1998?
Your answer should be compact. 0.71. What is the ratio of the Exports(as % of merchandise exports) in Uganda in 1997 to that in 1998?
Ensure brevity in your answer.  0. What is the ratio of the Exports(as % of merchandise exports) in Europe(all income levels) in 1997 to that in 2000?
Give a very brief answer. 0.83. What is the ratio of the Exports(as % of merchandise exports) of Hungary in 1997 to that in 2000?
Provide a short and direct response. 1.41. What is the ratio of the Exports(as % of merchandise exports) in St. Lucia in 1997 to that in 2000?
Your answer should be compact. 0.15. What is the ratio of the Exports(as % of merchandise exports) in Uganda in 1997 to that in 2000?
Make the answer very short. 0. What is the ratio of the Exports(as % of merchandise exports) in Europe(all income levels) in 1997 to that in 2001?
Offer a very short reply. 0.87. What is the ratio of the Exports(as % of merchandise exports) in Hungary in 1997 to that in 2001?
Make the answer very short. 1.45. What is the ratio of the Exports(as % of merchandise exports) in St. Lucia in 1997 to that in 2001?
Keep it short and to the point. 1.41. What is the ratio of the Exports(as % of merchandise exports) in Uganda in 1997 to that in 2001?
Keep it short and to the point. 0. What is the ratio of the Exports(as % of merchandise exports) in Europe(all income levels) in 1997 to that in 2002?
Provide a succinct answer. 0.87. What is the ratio of the Exports(as % of merchandise exports) in Hungary in 1997 to that in 2002?
Ensure brevity in your answer.  1.54. What is the ratio of the Exports(as % of merchandise exports) of St. Lucia in 1997 to that in 2002?
Ensure brevity in your answer.  175.12. What is the ratio of the Exports(as % of merchandise exports) in Uganda in 1997 to that in 2002?
Give a very brief answer. 0. What is the ratio of the Exports(as % of merchandise exports) in Europe(all income levels) in 1997 to that in 2005?
Your answer should be very brief. 0.69. What is the ratio of the Exports(as % of merchandise exports) in Hungary in 1997 to that in 2005?
Provide a short and direct response. 0.87. What is the ratio of the Exports(as % of merchandise exports) in St. Lucia in 1997 to that in 2005?
Make the answer very short. 0.81. What is the ratio of the Exports(as % of merchandise exports) of Uganda in 1997 to that in 2005?
Provide a short and direct response. 0. What is the ratio of the Exports(as % of merchandise exports) in Europe(all income levels) in 1997 to that in 2006?
Provide a short and direct response. 0.66. What is the ratio of the Exports(as % of merchandise exports) in Hungary in 1997 to that in 2006?
Your response must be concise. 0.96. What is the ratio of the Exports(as % of merchandise exports) of St. Lucia in 1997 to that in 2006?
Make the answer very short. 0.5. What is the ratio of the Exports(as % of merchandise exports) of Uganda in 1997 to that in 2006?
Make the answer very short. 0. What is the ratio of the Exports(as % of merchandise exports) of Europe(all income levels) in 1998 to that in 2000?
Offer a terse response. 0.7. What is the ratio of the Exports(as % of merchandise exports) in Hungary in 1998 to that in 2000?
Provide a short and direct response. 1.15. What is the ratio of the Exports(as % of merchandise exports) of St. Lucia in 1998 to that in 2000?
Ensure brevity in your answer.  0.22. What is the ratio of the Exports(as % of merchandise exports) of Uganda in 1998 to that in 2000?
Ensure brevity in your answer.  0.41. What is the ratio of the Exports(as % of merchandise exports) of Europe(all income levels) in 1998 to that in 2001?
Ensure brevity in your answer.  0.74. What is the ratio of the Exports(as % of merchandise exports) of Hungary in 1998 to that in 2001?
Offer a terse response. 1.18. What is the ratio of the Exports(as % of merchandise exports) in St. Lucia in 1998 to that in 2001?
Provide a succinct answer. 1.99. What is the ratio of the Exports(as % of merchandise exports) in Uganda in 1998 to that in 2001?
Keep it short and to the point. 0.81. What is the ratio of the Exports(as % of merchandise exports) in Europe(all income levels) in 1998 to that in 2002?
Offer a very short reply. 0.73. What is the ratio of the Exports(as % of merchandise exports) in Hungary in 1998 to that in 2002?
Your response must be concise. 1.25. What is the ratio of the Exports(as % of merchandise exports) of St. Lucia in 1998 to that in 2002?
Your response must be concise. 246.42. What is the ratio of the Exports(as % of merchandise exports) of Uganda in 1998 to that in 2002?
Give a very brief answer. 0.56. What is the ratio of the Exports(as % of merchandise exports) of Europe(all income levels) in 1998 to that in 2005?
Provide a succinct answer. 0.58. What is the ratio of the Exports(as % of merchandise exports) of Hungary in 1998 to that in 2005?
Offer a very short reply. 0.71. What is the ratio of the Exports(as % of merchandise exports) of St. Lucia in 1998 to that in 2005?
Offer a very short reply. 1.14. What is the ratio of the Exports(as % of merchandise exports) of Uganda in 1998 to that in 2005?
Give a very brief answer. 1.26. What is the ratio of the Exports(as % of merchandise exports) of Europe(all income levels) in 1998 to that in 2006?
Keep it short and to the point. 0.56. What is the ratio of the Exports(as % of merchandise exports) of Hungary in 1998 to that in 2006?
Give a very brief answer. 0.79. What is the ratio of the Exports(as % of merchandise exports) in St. Lucia in 1998 to that in 2006?
Your response must be concise. 0.7. What is the ratio of the Exports(as % of merchandise exports) of Uganda in 1998 to that in 2006?
Give a very brief answer. 0.47. What is the ratio of the Exports(as % of merchandise exports) in Europe(all income levels) in 2000 to that in 2001?
Keep it short and to the point. 1.05. What is the ratio of the Exports(as % of merchandise exports) in Hungary in 2000 to that in 2001?
Give a very brief answer. 1.03. What is the ratio of the Exports(as % of merchandise exports) of St. Lucia in 2000 to that in 2001?
Keep it short and to the point. 9.2. What is the ratio of the Exports(as % of merchandise exports) in Uganda in 2000 to that in 2001?
Offer a terse response. 1.96. What is the ratio of the Exports(as % of merchandise exports) in Europe(all income levels) in 2000 to that in 2002?
Provide a short and direct response. 1.04. What is the ratio of the Exports(as % of merchandise exports) in Hungary in 2000 to that in 2002?
Offer a terse response. 1.09. What is the ratio of the Exports(as % of merchandise exports) of St. Lucia in 2000 to that in 2002?
Provide a short and direct response. 1138.98. What is the ratio of the Exports(as % of merchandise exports) in Uganda in 2000 to that in 2002?
Your answer should be very brief. 1.35. What is the ratio of the Exports(as % of merchandise exports) of Europe(all income levels) in 2000 to that in 2005?
Provide a short and direct response. 0.83. What is the ratio of the Exports(as % of merchandise exports) of Hungary in 2000 to that in 2005?
Offer a terse response. 0.62. What is the ratio of the Exports(as % of merchandise exports) of St. Lucia in 2000 to that in 2005?
Your response must be concise. 5.28. What is the ratio of the Exports(as % of merchandise exports) in Uganda in 2000 to that in 2005?
Your response must be concise. 3.06. What is the ratio of the Exports(as % of merchandise exports) in Europe(all income levels) in 2000 to that in 2006?
Your answer should be very brief. 0.79. What is the ratio of the Exports(as % of merchandise exports) of Hungary in 2000 to that in 2006?
Keep it short and to the point. 0.68. What is the ratio of the Exports(as % of merchandise exports) of St. Lucia in 2000 to that in 2006?
Your response must be concise. 3.23. What is the ratio of the Exports(as % of merchandise exports) in Uganda in 2000 to that in 2006?
Offer a terse response. 1.13. What is the ratio of the Exports(as % of merchandise exports) of Hungary in 2001 to that in 2002?
Provide a short and direct response. 1.06. What is the ratio of the Exports(as % of merchandise exports) of St. Lucia in 2001 to that in 2002?
Your answer should be very brief. 123.86. What is the ratio of the Exports(as % of merchandise exports) in Uganda in 2001 to that in 2002?
Provide a succinct answer. 0.69. What is the ratio of the Exports(as % of merchandise exports) in Europe(all income levels) in 2001 to that in 2005?
Keep it short and to the point. 0.79. What is the ratio of the Exports(as % of merchandise exports) in Hungary in 2001 to that in 2005?
Your response must be concise. 0.6. What is the ratio of the Exports(as % of merchandise exports) in St. Lucia in 2001 to that in 2005?
Your answer should be compact. 0.57. What is the ratio of the Exports(as % of merchandise exports) of Uganda in 2001 to that in 2005?
Offer a terse response. 1.56. What is the ratio of the Exports(as % of merchandise exports) in Europe(all income levels) in 2001 to that in 2006?
Provide a succinct answer. 0.76. What is the ratio of the Exports(as % of merchandise exports) in Hungary in 2001 to that in 2006?
Offer a terse response. 0.66. What is the ratio of the Exports(as % of merchandise exports) in St. Lucia in 2001 to that in 2006?
Make the answer very short. 0.35. What is the ratio of the Exports(as % of merchandise exports) in Uganda in 2001 to that in 2006?
Your answer should be compact. 0.58. What is the ratio of the Exports(as % of merchandise exports) in Europe(all income levels) in 2002 to that in 2005?
Your response must be concise. 0.79. What is the ratio of the Exports(as % of merchandise exports) in Hungary in 2002 to that in 2005?
Your answer should be compact. 0.57. What is the ratio of the Exports(as % of merchandise exports) in St. Lucia in 2002 to that in 2005?
Offer a terse response. 0. What is the ratio of the Exports(as % of merchandise exports) in Uganda in 2002 to that in 2005?
Give a very brief answer. 2.26. What is the ratio of the Exports(as % of merchandise exports) of Europe(all income levels) in 2002 to that in 2006?
Make the answer very short. 0.76. What is the ratio of the Exports(as % of merchandise exports) in Hungary in 2002 to that in 2006?
Your answer should be very brief. 0.63. What is the ratio of the Exports(as % of merchandise exports) in St. Lucia in 2002 to that in 2006?
Offer a terse response. 0. What is the ratio of the Exports(as % of merchandise exports) in Uganda in 2002 to that in 2006?
Offer a very short reply. 0.84. What is the ratio of the Exports(as % of merchandise exports) of Europe(all income levels) in 2005 to that in 2006?
Give a very brief answer. 0.96. What is the ratio of the Exports(as % of merchandise exports) in Hungary in 2005 to that in 2006?
Your answer should be compact. 1.1. What is the ratio of the Exports(as % of merchandise exports) of St. Lucia in 2005 to that in 2006?
Offer a very short reply. 0.61. What is the ratio of the Exports(as % of merchandise exports) of Uganda in 2005 to that in 2006?
Provide a short and direct response. 0.37. What is the difference between the highest and the second highest Exports(as % of merchandise exports) of Europe(all income levels)?
Your answer should be very brief. 0.43. What is the difference between the highest and the second highest Exports(as % of merchandise exports) of Hungary?
Ensure brevity in your answer.  0.78. What is the difference between the highest and the second highest Exports(as % of merchandise exports) in St. Lucia?
Provide a succinct answer. 0. What is the difference between the highest and the second highest Exports(as % of merchandise exports) in Uganda?
Your response must be concise. 0.66. What is the difference between the highest and the lowest Exports(as % of merchandise exports) of Europe(all income levels)?
Offer a terse response. 4.49. What is the difference between the highest and the lowest Exports(as % of merchandise exports) of Hungary?
Your answer should be compact. 1.91. What is the difference between the highest and the lowest Exports(as % of merchandise exports) in St. Lucia?
Make the answer very short. 0.01. What is the difference between the highest and the lowest Exports(as % of merchandise exports) of Uganda?
Ensure brevity in your answer.  5.68. 